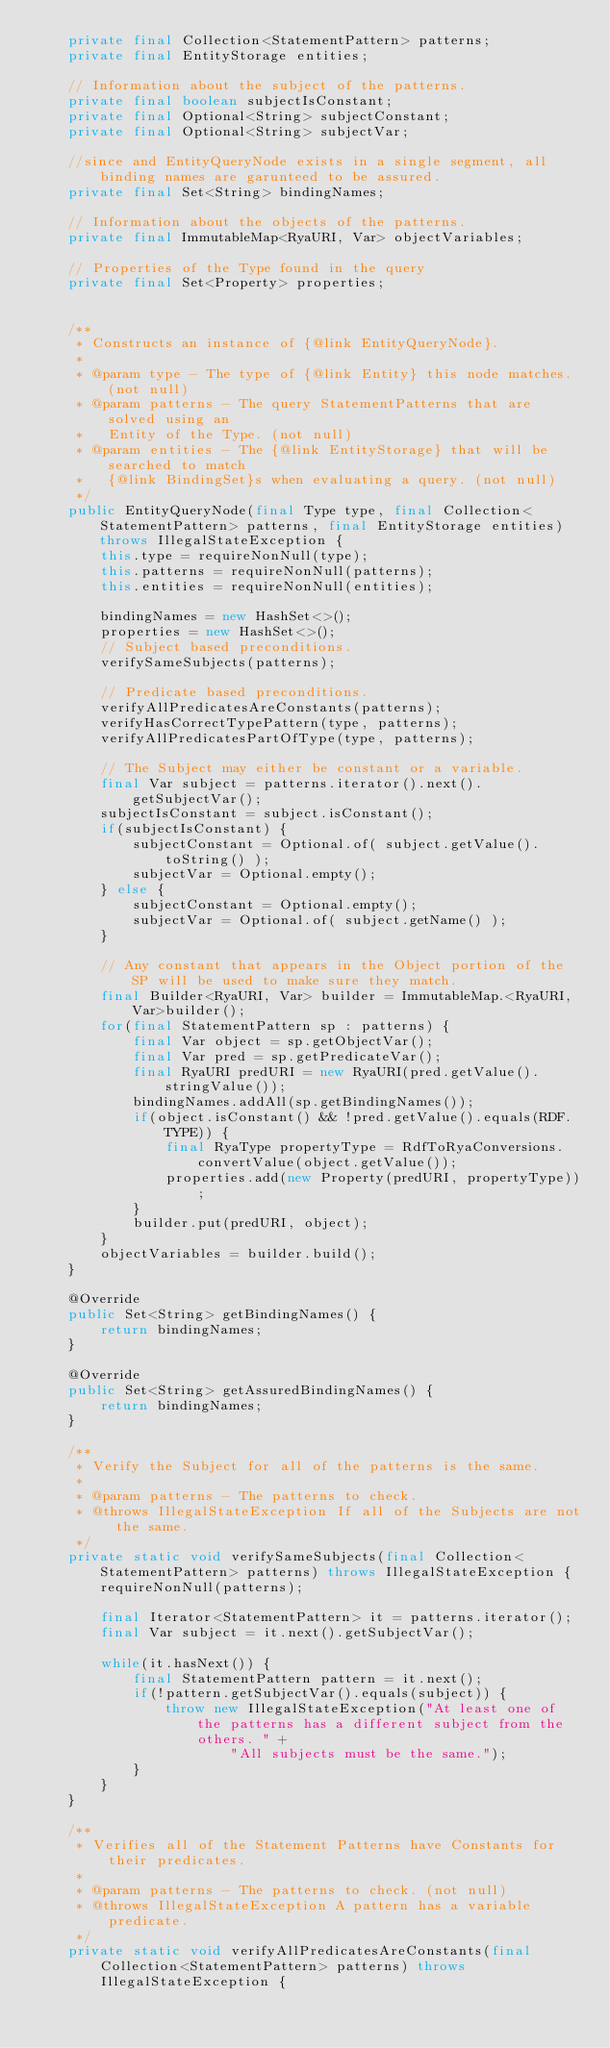Convert code to text. <code><loc_0><loc_0><loc_500><loc_500><_Java_>    private final Collection<StatementPattern> patterns;
    private final EntityStorage entities;

    // Information about the subject of the patterns.
    private final boolean subjectIsConstant;
    private final Optional<String> subjectConstant;
    private final Optional<String> subjectVar;

    //since and EntityQueryNode exists in a single segment, all binding names are garunteed to be assured.
    private final Set<String> bindingNames;

    // Information about the objects of the patterns.
    private final ImmutableMap<RyaURI, Var> objectVariables;

    // Properties of the Type found in the query
    private final Set<Property> properties;


    /**
     * Constructs an instance of {@link EntityQueryNode}.
     *
     * @param type - The type of {@link Entity} this node matches. (not null)
     * @param patterns - The query StatementPatterns that are solved using an
     *   Entity of the Type. (not null)
     * @param entities - The {@link EntityStorage} that will be searched to match
     *   {@link BindingSet}s when evaluating a query. (not null)
     */
    public EntityQueryNode(final Type type, final Collection<StatementPattern> patterns, final EntityStorage entities) throws IllegalStateException {
        this.type = requireNonNull(type);
        this.patterns = requireNonNull(patterns);
        this.entities = requireNonNull(entities);

        bindingNames = new HashSet<>();
        properties = new HashSet<>();
        // Subject based preconditions.
        verifySameSubjects(patterns);

        // Predicate based preconditions.
        verifyAllPredicatesAreConstants(patterns);
        verifyHasCorrectTypePattern(type, patterns);
        verifyAllPredicatesPartOfType(type, patterns);

        // The Subject may either be constant or a variable.
        final Var subject = patterns.iterator().next().getSubjectVar();
        subjectIsConstant = subject.isConstant();
        if(subjectIsConstant) {
            subjectConstant = Optional.of( subject.getValue().toString() );
            subjectVar = Optional.empty();
        } else {
            subjectConstant = Optional.empty();
            subjectVar = Optional.of( subject.getName() );
        }

        // Any constant that appears in the Object portion of the SP will be used to make sure they match.
        final Builder<RyaURI, Var> builder = ImmutableMap.<RyaURI, Var>builder();
        for(final StatementPattern sp : patterns) {
            final Var object = sp.getObjectVar();
            final Var pred = sp.getPredicateVar();
            final RyaURI predURI = new RyaURI(pred.getValue().stringValue());
            bindingNames.addAll(sp.getBindingNames());
            if(object.isConstant() && !pred.getValue().equals(RDF.TYPE)) {
                final RyaType propertyType = RdfToRyaConversions.convertValue(object.getValue());
                properties.add(new Property(predURI, propertyType));
            }
            builder.put(predURI, object);
        }
        objectVariables = builder.build();
    }

    @Override
    public Set<String> getBindingNames() {
        return bindingNames;
    }

    @Override
    public Set<String> getAssuredBindingNames() {
        return bindingNames;
    }

    /**
     * Verify the Subject for all of the patterns is the same.
     *
     * @param patterns - The patterns to check.
     * @throws IllegalStateException If all of the Subjects are not the same.
     */
    private static void verifySameSubjects(final Collection<StatementPattern> patterns) throws IllegalStateException {
        requireNonNull(patterns);

        final Iterator<StatementPattern> it = patterns.iterator();
        final Var subject = it.next().getSubjectVar();

        while(it.hasNext()) {
            final StatementPattern pattern = it.next();
            if(!pattern.getSubjectVar().equals(subject)) {
                throw new IllegalStateException("At least one of the patterns has a different subject from the others. " +
                        "All subjects must be the same.");
            }
        }
    }

    /**
     * Verifies all of the Statement Patterns have Constants for their predicates.
     *
     * @param patterns - The patterns to check. (not null)
     * @throws IllegalStateException A pattern has a variable predicate.
     */
    private static void verifyAllPredicatesAreConstants(final Collection<StatementPattern> patterns) throws IllegalStateException {</code> 